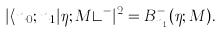<formula> <loc_0><loc_0><loc_500><loc_500>| \langle n _ { 0 } ; n _ { 1 } | \eta ; M \rangle ^ { - } | ^ { 2 } = B _ { n _ { 1 } } ^ { - } ( \eta ; M ) .</formula> 